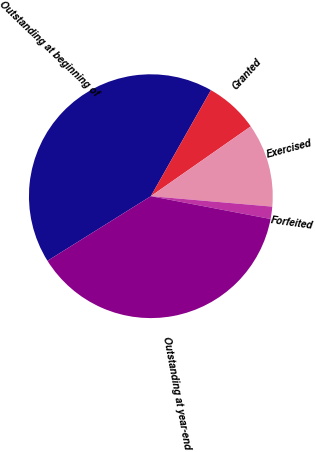Convert chart to OTSL. <chart><loc_0><loc_0><loc_500><loc_500><pie_chart><fcel>Outstanding at beginning of<fcel>Granted<fcel>Exercised<fcel>Forfeited<fcel>Outstanding at year-end<nl><fcel>42.1%<fcel>7.09%<fcel>11.07%<fcel>1.63%<fcel>38.11%<nl></chart> 